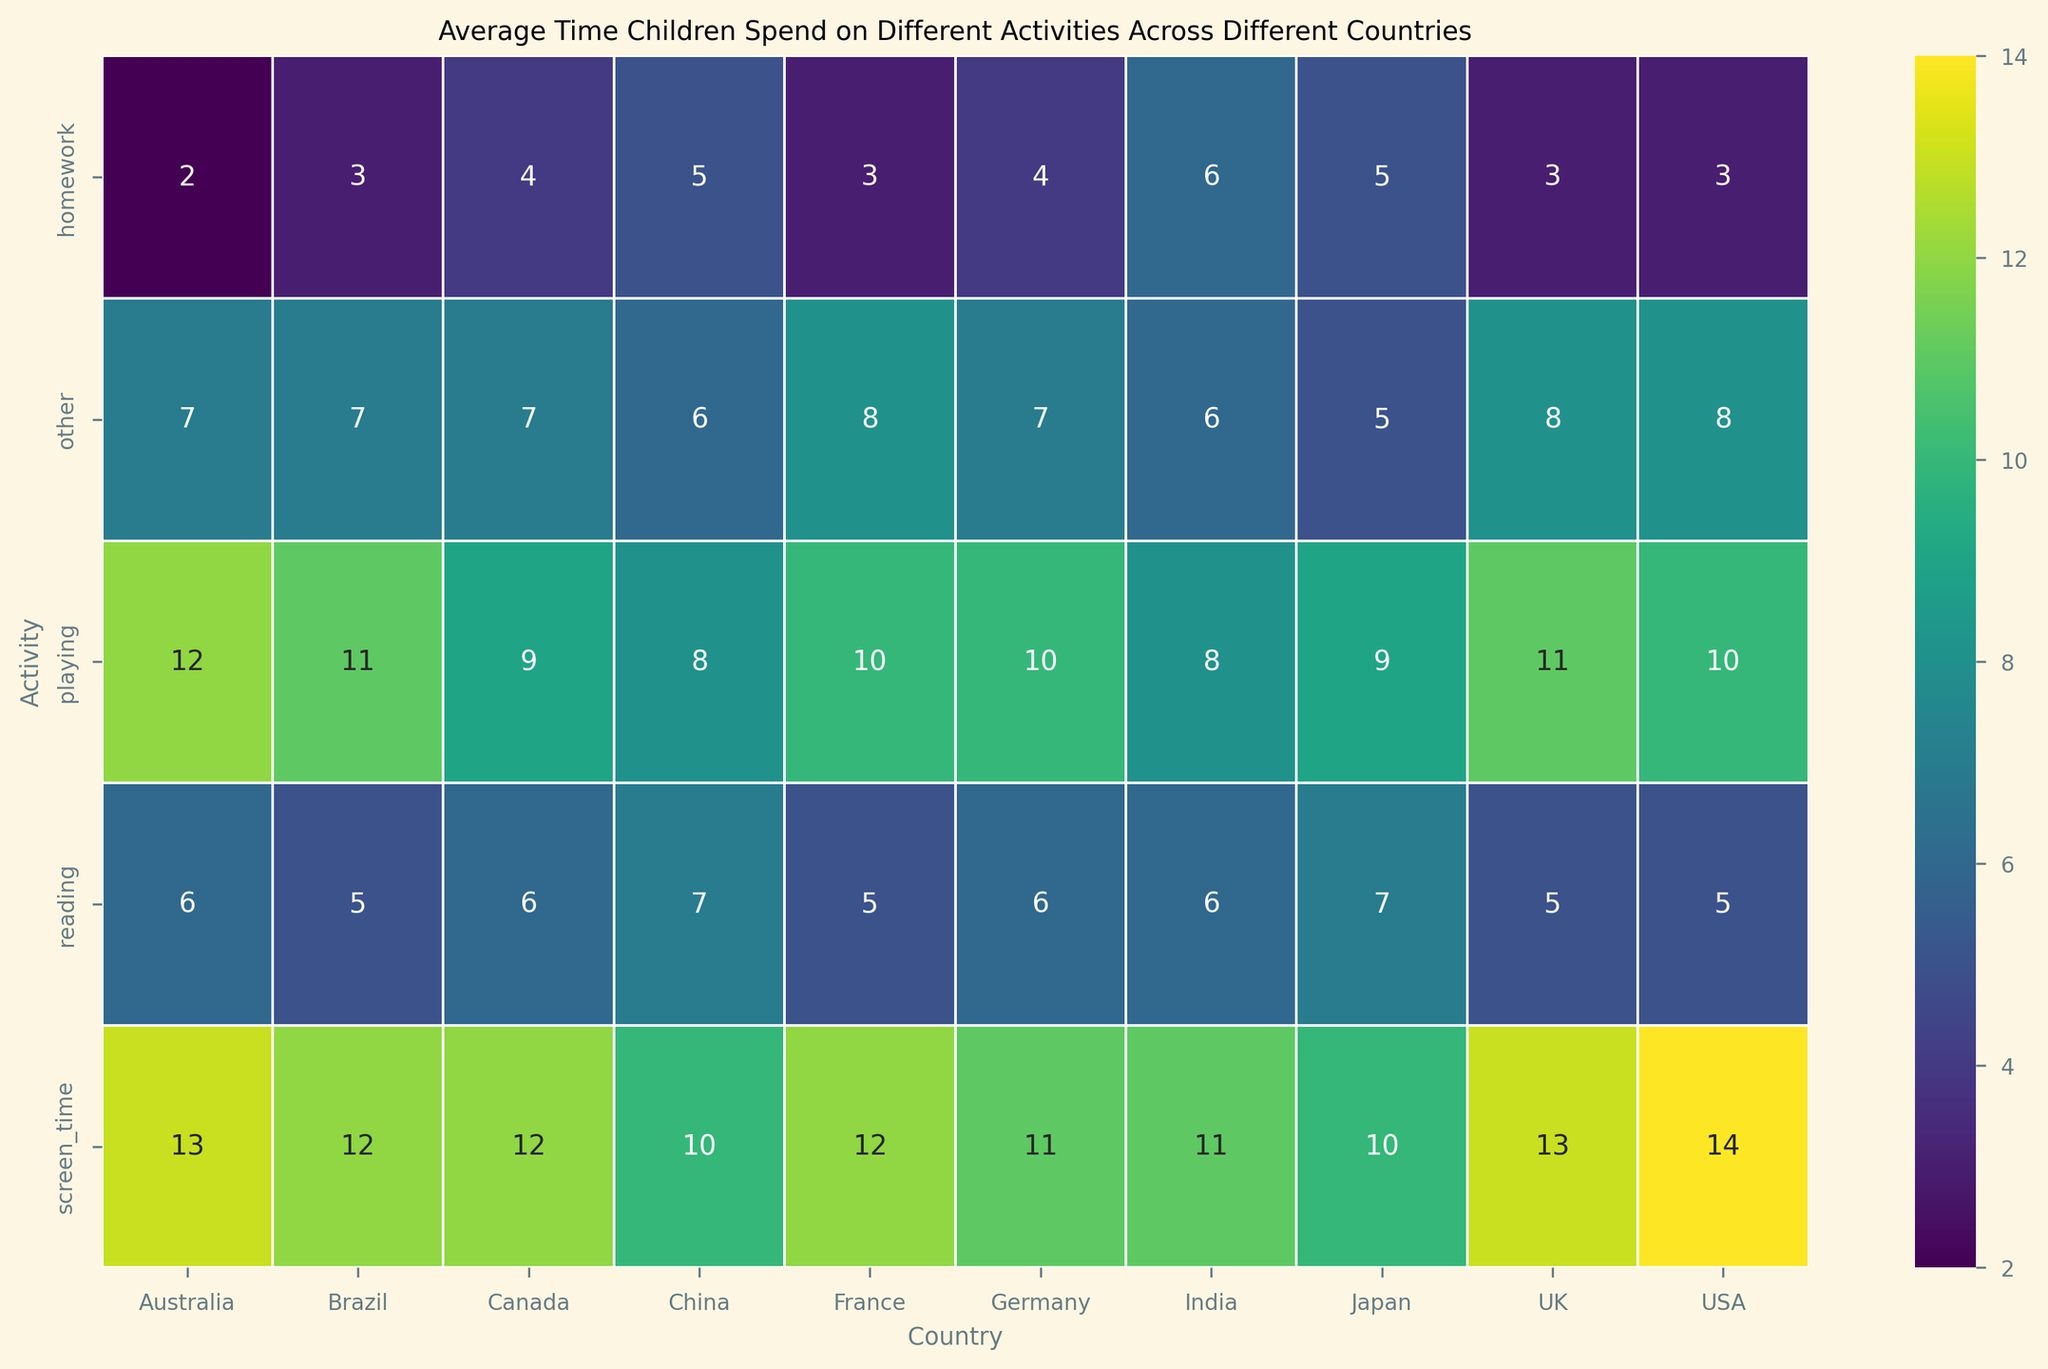Which country has the highest average time spent on playing? By glancing at the heatmap and locating the "playing" row, we can identify which country has the largest numerical value. Australia spends 12 hours, which is the highest.
Answer: Australia Which activity do children in Japan spend the most time on? Look at the row for Japan and identify the column with the highest number. The highest number in Japan's row is 10 hours for screen time.
Answer: Screen time Is the average time children spend on reading higher in China or Germany? Focus on the reading row and compare the values for China and Germany. China has 7 hours, and Germany has 6 hours.
Answer: China What is the total average time spent on all activities by children in the USA? Sum the values for the USA across all activities: 5 (reading) + 10 (playing) + 14 (screen time) + 3 (homework) + 8 (other) = 40 hours.
Answer: 40 hours Do children in Brazil spend more time on playing or screen time? Look at Brazil's row and compare the values for playing and screen time. Both playing and screen time are 11 hours.
Answer: They spend the same amount of time What is the difference in average time spent on homework between India and Australia? Look at the homework row and subtract Australia’s value from India’s: 6 (India) - 2 (Australia) = 4 hours.
Answer: 4 hours Which two countries have the same average time spent on other activities? Examine the "other" row and find two countries with the same value. Germany and Canada both have 7 hours.
Answer: Germany and Canada What is the average time spent on reading across all countries? Add up all the values for reading and divide by the number of countries: (5+6+5+6+5+6+7+6+5+7)/10 = 5.8 hours.
Answer: 5.8 hours Which country has the least average time spent on homework? Locate the homework row and find the country with the smallest number. Australia has 2 hours, which is the least.
Answer: Australia In which country do children spend equal time on reading and other activities? Find the countries where the values for reading and other are the same. Japan has 7 hours for both reading and other.
Answer: Japan 